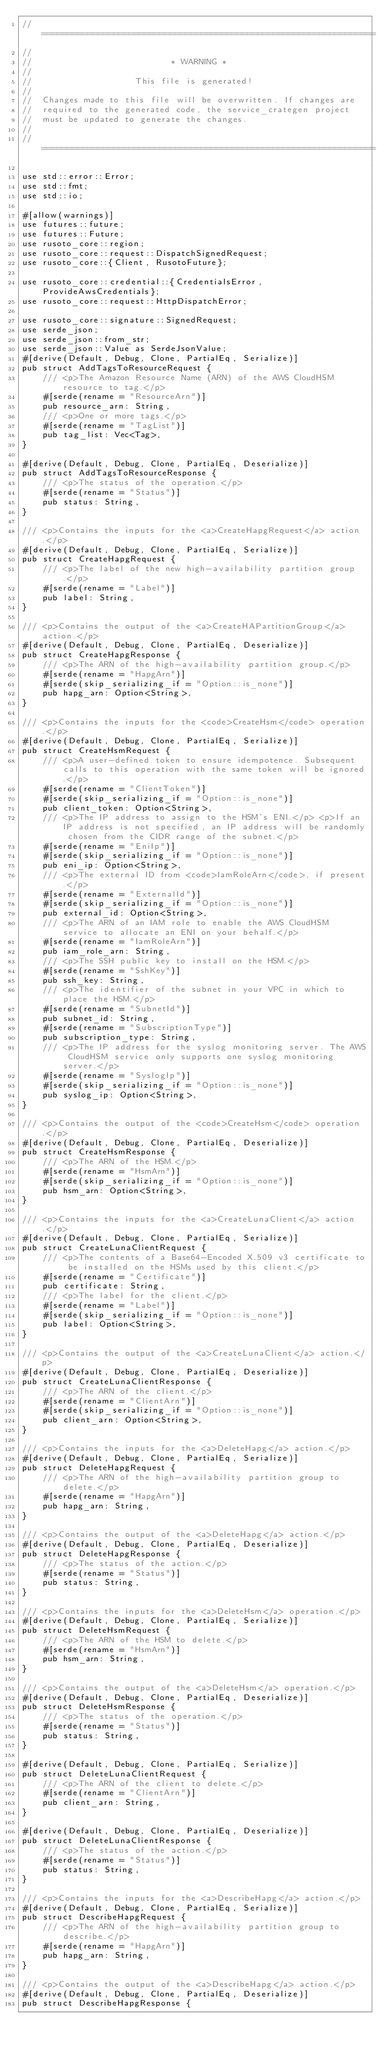Convert code to text. <code><loc_0><loc_0><loc_500><loc_500><_Rust_>// =================================================================
//
//                           * WARNING *
//
//                    This file is generated!
//
//  Changes made to this file will be overwritten. If changes are
//  required to the generated code, the service_crategen project
//  must be updated to generate the changes.
//
// =================================================================

use std::error::Error;
use std::fmt;
use std::io;

#[allow(warnings)]
use futures::future;
use futures::Future;
use rusoto_core::region;
use rusoto_core::request::DispatchSignedRequest;
use rusoto_core::{Client, RusotoFuture};

use rusoto_core::credential::{CredentialsError, ProvideAwsCredentials};
use rusoto_core::request::HttpDispatchError;

use rusoto_core::signature::SignedRequest;
use serde_json;
use serde_json::from_str;
use serde_json::Value as SerdeJsonValue;
#[derive(Default, Debug, Clone, PartialEq, Serialize)]
pub struct AddTagsToResourceRequest {
    /// <p>The Amazon Resource Name (ARN) of the AWS CloudHSM resource to tag.</p>
    #[serde(rename = "ResourceArn")]
    pub resource_arn: String,
    /// <p>One or more tags.</p>
    #[serde(rename = "TagList")]
    pub tag_list: Vec<Tag>,
}

#[derive(Default, Debug, Clone, PartialEq, Deserialize)]
pub struct AddTagsToResourceResponse {
    /// <p>The status of the operation.</p>
    #[serde(rename = "Status")]
    pub status: String,
}

/// <p>Contains the inputs for the <a>CreateHapgRequest</a> action.</p>
#[derive(Default, Debug, Clone, PartialEq, Serialize)]
pub struct CreateHapgRequest {
    /// <p>The label of the new high-availability partition group.</p>
    #[serde(rename = "Label")]
    pub label: String,
}

/// <p>Contains the output of the <a>CreateHAPartitionGroup</a> action.</p>
#[derive(Default, Debug, Clone, PartialEq, Deserialize)]
pub struct CreateHapgResponse {
    /// <p>The ARN of the high-availability partition group.</p>
    #[serde(rename = "HapgArn")]
    #[serde(skip_serializing_if = "Option::is_none")]
    pub hapg_arn: Option<String>,
}

/// <p>Contains the inputs for the <code>CreateHsm</code> operation.</p>
#[derive(Default, Debug, Clone, PartialEq, Serialize)]
pub struct CreateHsmRequest {
    /// <p>A user-defined token to ensure idempotence. Subsequent calls to this operation with the same token will be ignored.</p>
    #[serde(rename = "ClientToken")]
    #[serde(skip_serializing_if = "Option::is_none")]
    pub client_token: Option<String>,
    /// <p>The IP address to assign to the HSM's ENI.</p> <p>If an IP address is not specified, an IP address will be randomly chosen from the CIDR range of the subnet.</p>
    #[serde(rename = "EniIp")]
    #[serde(skip_serializing_if = "Option::is_none")]
    pub eni_ip: Option<String>,
    /// <p>The external ID from <code>IamRoleArn</code>, if present.</p>
    #[serde(rename = "ExternalId")]
    #[serde(skip_serializing_if = "Option::is_none")]
    pub external_id: Option<String>,
    /// <p>The ARN of an IAM role to enable the AWS CloudHSM service to allocate an ENI on your behalf.</p>
    #[serde(rename = "IamRoleArn")]
    pub iam_role_arn: String,
    /// <p>The SSH public key to install on the HSM.</p>
    #[serde(rename = "SshKey")]
    pub ssh_key: String,
    /// <p>The identifier of the subnet in your VPC in which to place the HSM.</p>
    #[serde(rename = "SubnetId")]
    pub subnet_id: String,
    #[serde(rename = "SubscriptionType")]
    pub subscription_type: String,
    /// <p>The IP address for the syslog monitoring server. The AWS CloudHSM service only supports one syslog monitoring server.</p>
    #[serde(rename = "SyslogIp")]
    #[serde(skip_serializing_if = "Option::is_none")]
    pub syslog_ip: Option<String>,
}

/// <p>Contains the output of the <code>CreateHsm</code> operation.</p>
#[derive(Default, Debug, Clone, PartialEq, Deserialize)]
pub struct CreateHsmResponse {
    /// <p>The ARN of the HSM.</p>
    #[serde(rename = "HsmArn")]
    #[serde(skip_serializing_if = "Option::is_none")]
    pub hsm_arn: Option<String>,
}

/// <p>Contains the inputs for the <a>CreateLunaClient</a> action.</p>
#[derive(Default, Debug, Clone, PartialEq, Serialize)]
pub struct CreateLunaClientRequest {
    /// <p>The contents of a Base64-Encoded X.509 v3 certificate to be installed on the HSMs used by this client.</p>
    #[serde(rename = "Certificate")]
    pub certificate: String,
    /// <p>The label for the client.</p>
    #[serde(rename = "Label")]
    #[serde(skip_serializing_if = "Option::is_none")]
    pub label: Option<String>,
}

/// <p>Contains the output of the <a>CreateLunaClient</a> action.</p>
#[derive(Default, Debug, Clone, PartialEq, Deserialize)]
pub struct CreateLunaClientResponse {
    /// <p>The ARN of the client.</p>
    #[serde(rename = "ClientArn")]
    #[serde(skip_serializing_if = "Option::is_none")]
    pub client_arn: Option<String>,
}

/// <p>Contains the inputs for the <a>DeleteHapg</a> action.</p>
#[derive(Default, Debug, Clone, PartialEq, Serialize)]
pub struct DeleteHapgRequest {
    /// <p>The ARN of the high-availability partition group to delete.</p>
    #[serde(rename = "HapgArn")]
    pub hapg_arn: String,
}

/// <p>Contains the output of the <a>DeleteHapg</a> action.</p>
#[derive(Default, Debug, Clone, PartialEq, Deserialize)]
pub struct DeleteHapgResponse {
    /// <p>The status of the action.</p>
    #[serde(rename = "Status")]
    pub status: String,
}

/// <p>Contains the inputs for the <a>DeleteHsm</a> operation.</p>
#[derive(Default, Debug, Clone, PartialEq, Serialize)]
pub struct DeleteHsmRequest {
    /// <p>The ARN of the HSM to delete.</p>
    #[serde(rename = "HsmArn")]
    pub hsm_arn: String,
}

/// <p>Contains the output of the <a>DeleteHsm</a> operation.</p>
#[derive(Default, Debug, Clone, PartialEq, Deserialize)]
pub struct DeleteHsmResponse {
    /// <p>The status of the operation.</p>
    #[serde(rename = "Status")]
    pub status: String,
}

#[derive(Default, Debug, Clone, PartialEq, Serialize)]
pub struct DeleteLunaClientRequest {
    /// <p>The ARN of the client to delete.</p>
    #[serde(rename = "ClientArn")]
    pub client_arn: String,
}

#[derive(Default, Debug, Clone, PartialEq, Deserialize)]
pub struct DeleteLunaClientResponse {
    /// <p>The status of the action.</p>
    #[serde(rename = "Status")]
    pub status: String,
}

/// <p>Contains the inputs for the <a>DescribeHapg</a> action.</p>
#[derive(Default, Debug, Clone, PartialEq, Serialize)]
pub struct DescribeHapgRequest {
    /// <p>The ARN of the high-availability partition group to describe.</p>
    #[serde(rename = "HapgArn")]
    pub hapg_arn: String,
}

/// <p>Contains the output of the <a>DescribeHapg</a> action.</p>
#[derive(Default, Debug, Clone, PartialEq, Deserialize)]
pub struct DescribeHapgResponse {</code> 